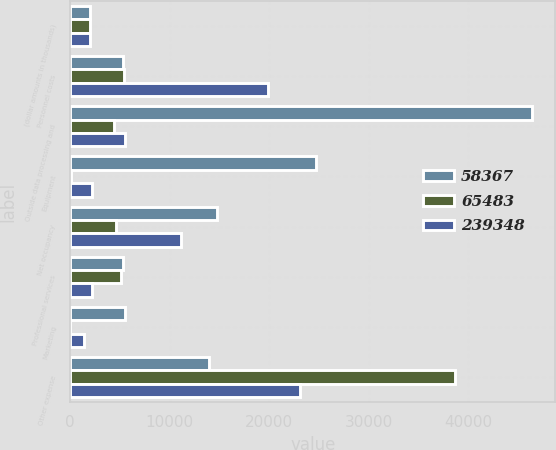Convert chart. <chart><loc_0><loc_0><loc_500><loc_500><stacked_bar_chart><ecel><fcel>(dollar amounts in thousands)<fcel>Personnel costs<fcel>Outside data processing and<fcel>Equipment<fcel>Net occupancy<fcel>Professional services<fcel>Marketing<fcel>Other expense<nl><fcel>58367<fcel>2016<fcel>5272<fcel>46467<fcel>24742<fcel>14772<fcel>5272<fcel>5520<fcel>14010<nl><fcel>65483<fcel>2015<fcel>5457<fcel>4365<fcel>110<fcel>4587<fcel>5087<fcel>28<fcel>38733<nl><fcel>239348<fcel>2014<fcel>19850<fcel>5507<fcel>2248<fcel>11153<fcel>2228<fcel>1357<fcel>23140<nl></chart> 